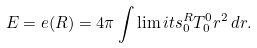Convert formula to latex. <formula><loc_0><loc_0><loc_500><loc_500>E = e ( R ) = 4 \pi \int \lim i t s _ { 0 } ^ { R } T _ { 0 } ^ { 0 } r ^ { 2 } \, d r .</formula> 